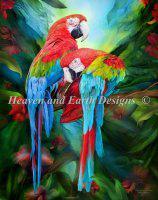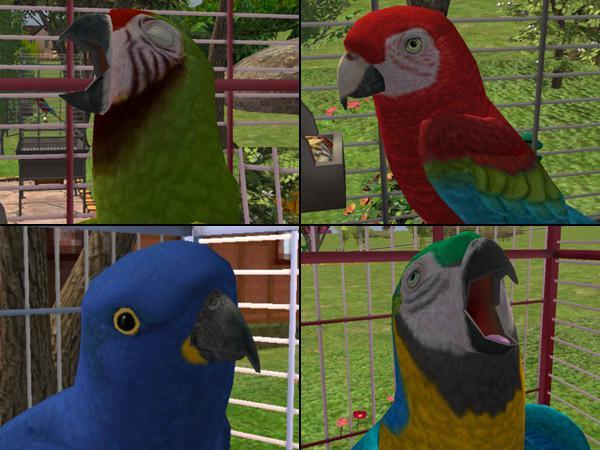The first image is the image on the left, the second image is the image on the right. Examine the images to the left and right. Is the description "All birds have yellow and blue coloring and all birds are in flight." accurate? Answer yes or no. No. The first image is the image on the left, the second image is the image on the right. Analyze the images presented: Is the assertion "All of the colorful birds are flying in the air." valid? Answer yes or no. No. 